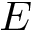Convert formula to latex. <formula><loc_0><loc_0><loc_500><loc_500>E</formula> 